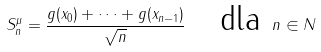Convert formula to latex. <formula><loc_0><loc_0><loc_500><loc_500>S _ { n } ^ { \mu } = \frac { g ( x _ { 0 } ) + \dots + g ( x _ { n - 1 } ) } { \sqrt { n } } \quad \text {dla } n \in N</formula> 